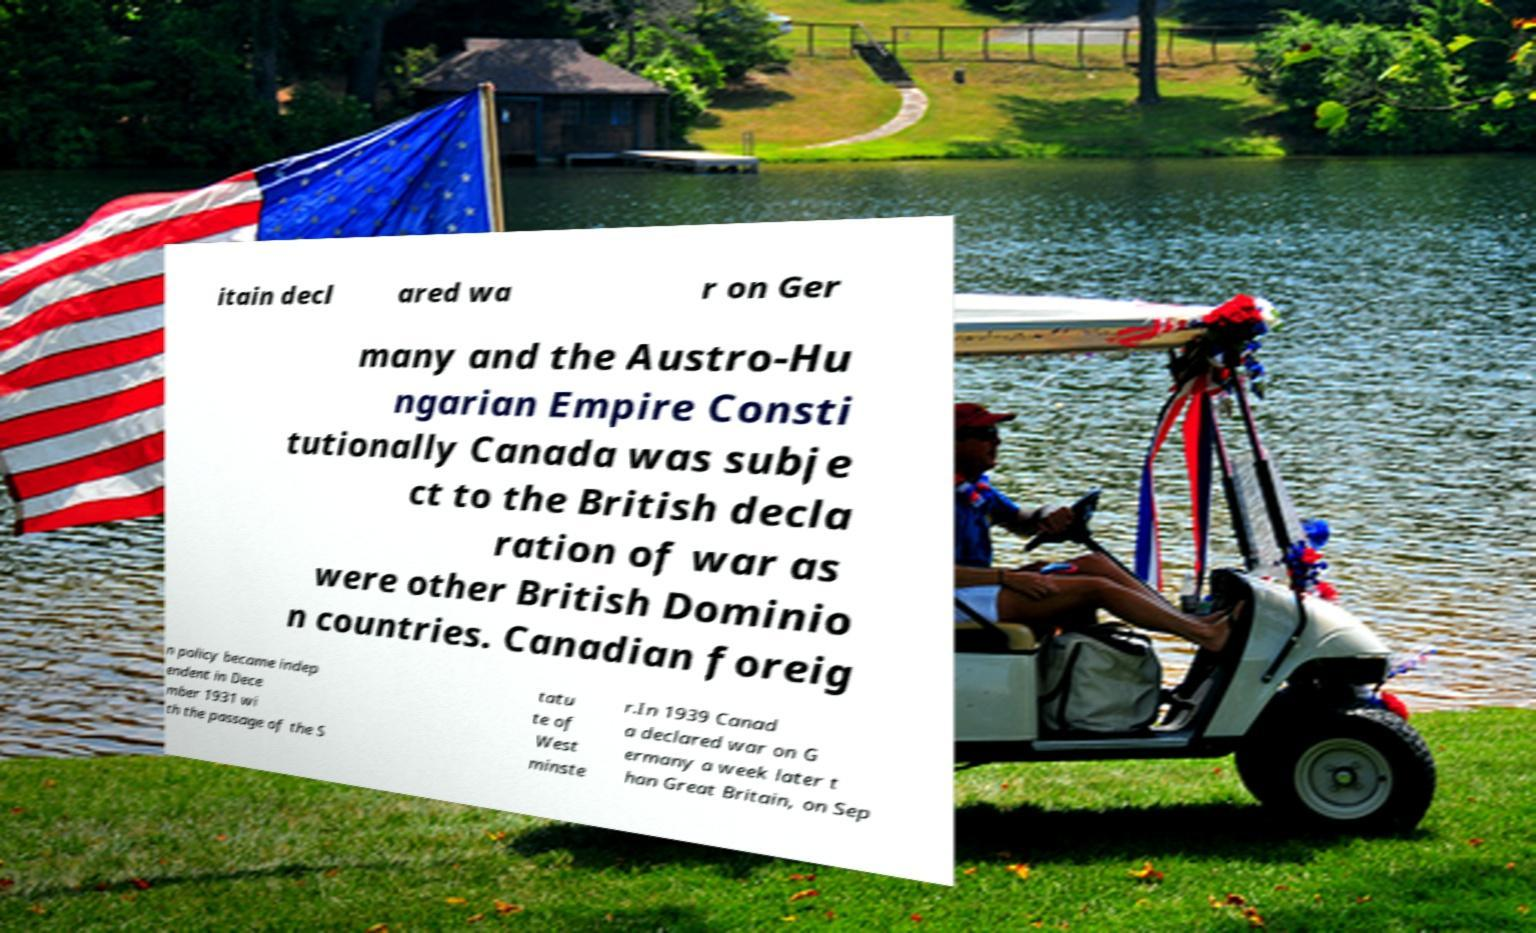What messages or text are displayed in this image? I need them in a readable, typed format. itain decl ared wa r on Ger many and the Austro-Hu ngarian Empire Consti tutionally Canada was subje ct to the British decla ration of war as were other British Dominio n countries. Canadian foreig n policy became indep endent in Dece mber 1931 wi th the passage of the S tatu te of West minste r.In 1939 Canad a declared war on G ermany a week later t han Great Britain, on Sep 